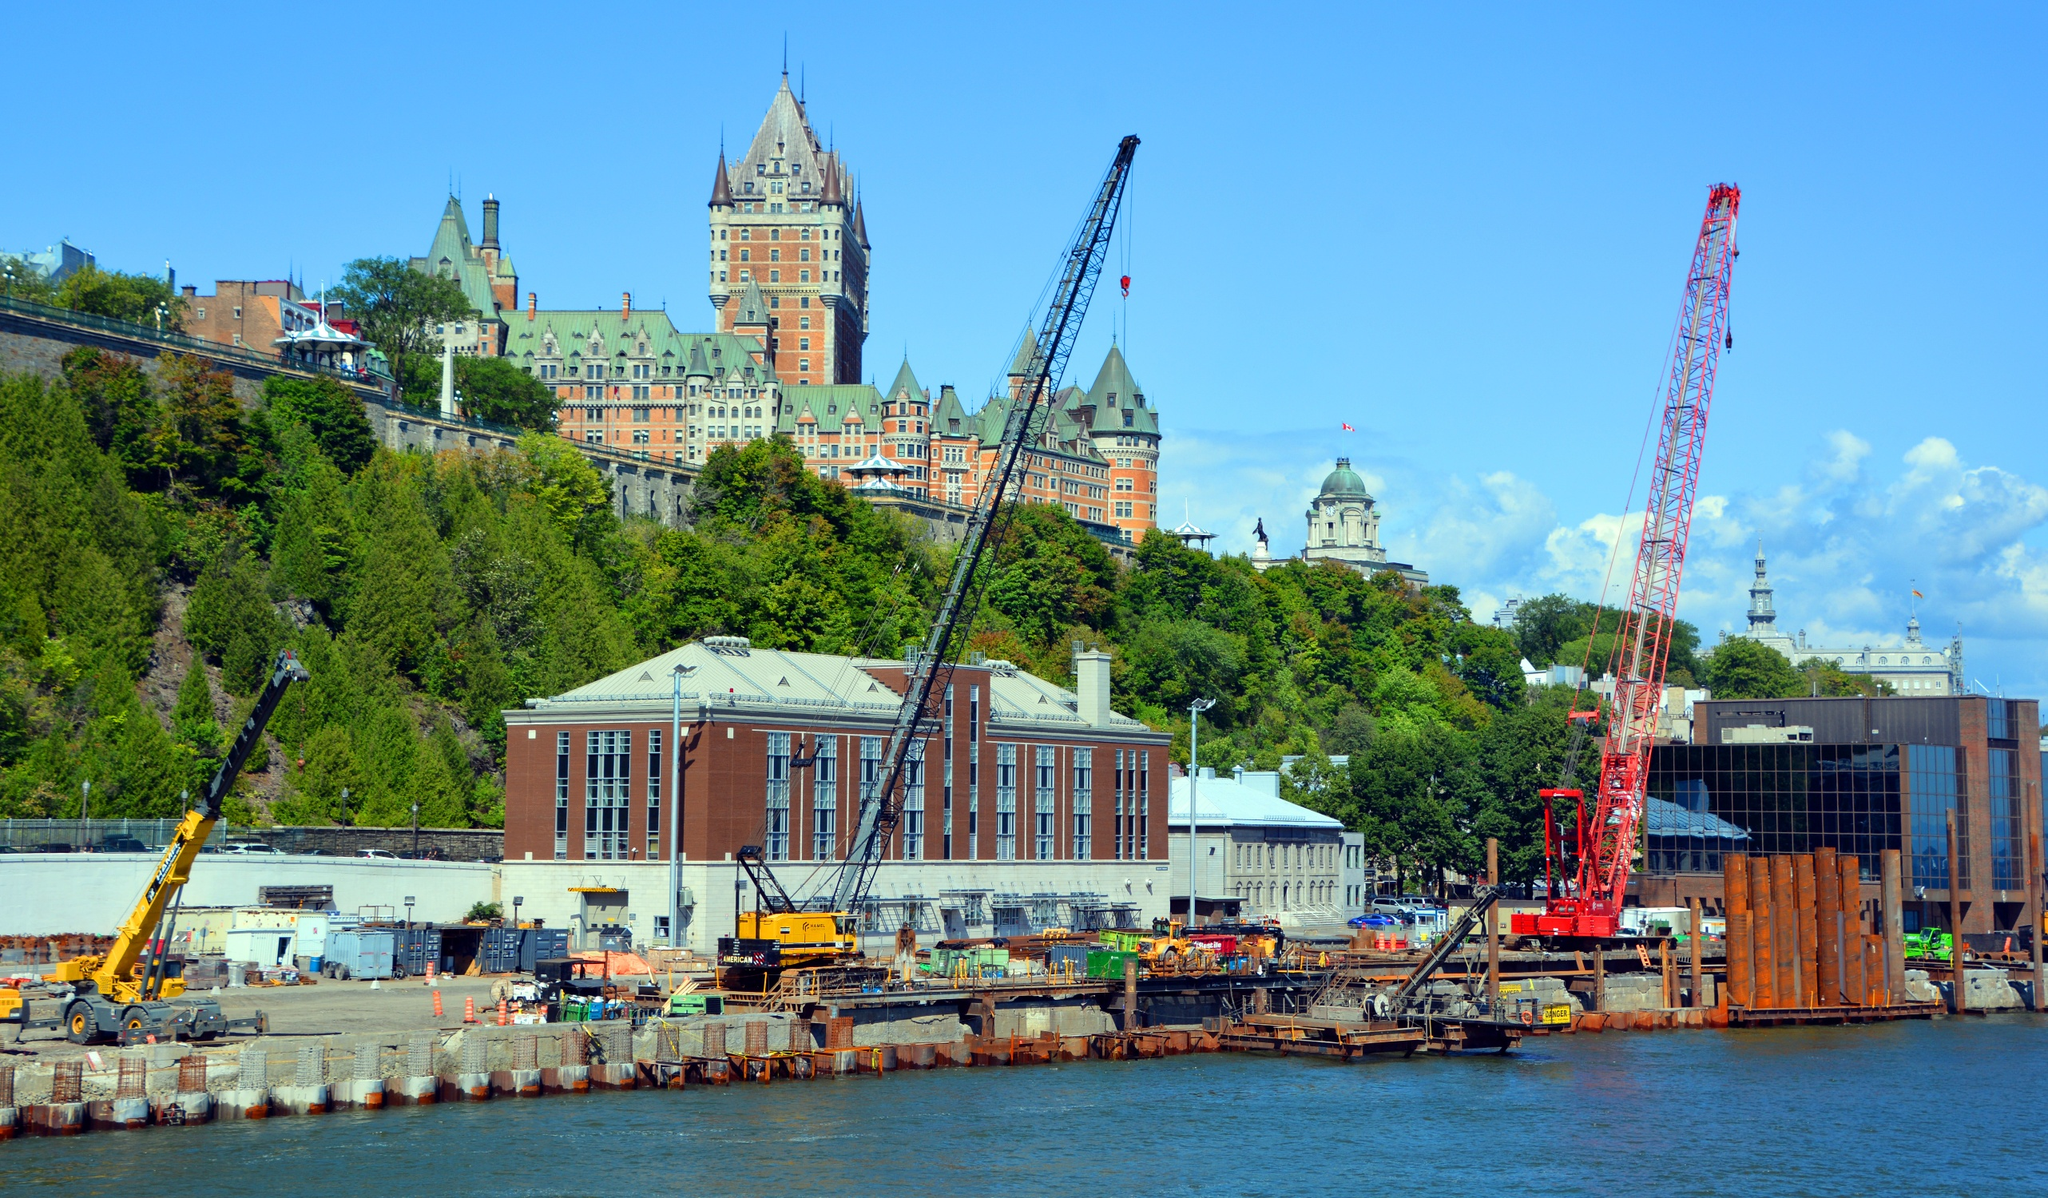Explore the history and cultural significance of the Château Frontenac. The Château Frontenac, built in 1893, is a grand railway hotel constructed by the Canadian Pacific Railway. With its distinctive châteauesque architectural style, it has become a symbol of Quebec City. Designed by architect Bruce Price, the hotel was conceived to promote luxurious travel by the Canadian railway system. Over the years, it has hosted numerous dignitaries and historical events, especially during the Quebec Conference of 1943, where Allied leaders strategized during World War II. Today, it stands not only as an opulent accommodation but also as a living monument to North America's rich history and cultural evolution. Can you elaborate on any significant events hosted at Château Frontenac? One of the most significant events hosted at the Château Frontenac was the 1943 Quebec Conference during World War II. This top-secret military conference brought together President Franklin D. Roosevelt of the United States, British Prime Minister Winston Churchill, and Canadian Prime Minister William Lyon Mackenzie King to discuss military strategies for the war and post-war plans. It was a pivotal moment in Allied history, resulting in significant military decisions, including the planning of the D-Day invasion. This conference not only underscores the hotel's historical importance but also its role in shaping global events. Imagine Château Frontenac as a character in a fantasy novel. What role would it play? Envision the Château Frontenac as the enchanted stronghold of an ancient order of secretive, wise sorcerers. Rising majestically on a hill overlooking a mystical city, its turrets, and copper-roofed spires glisten under moonlight with magical energy. The castle's inner chambers, filled with arcane artifacts and legendary tomes, serve as the epicenter of supernatural knowledge and power. Hidden passages and grand halls echo the whispers of spells and the stories of long-forgotten heroes. Its presence commands respect and awe, standing as a guardian of forgotten lore and a beacon of hope and wisdom in a world plagued by dark forces. 